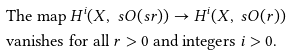<formula> <loc_0><loc_0><loc_500><loc_500>& \text {The map } H ^ { i } ( X , \ s O ( s r ) ) \to H ^ { i } ( X , \ s O ( r ) ) \\ & \text {vanishes for all $r>0$ and integers $i>0$.}</formula> 